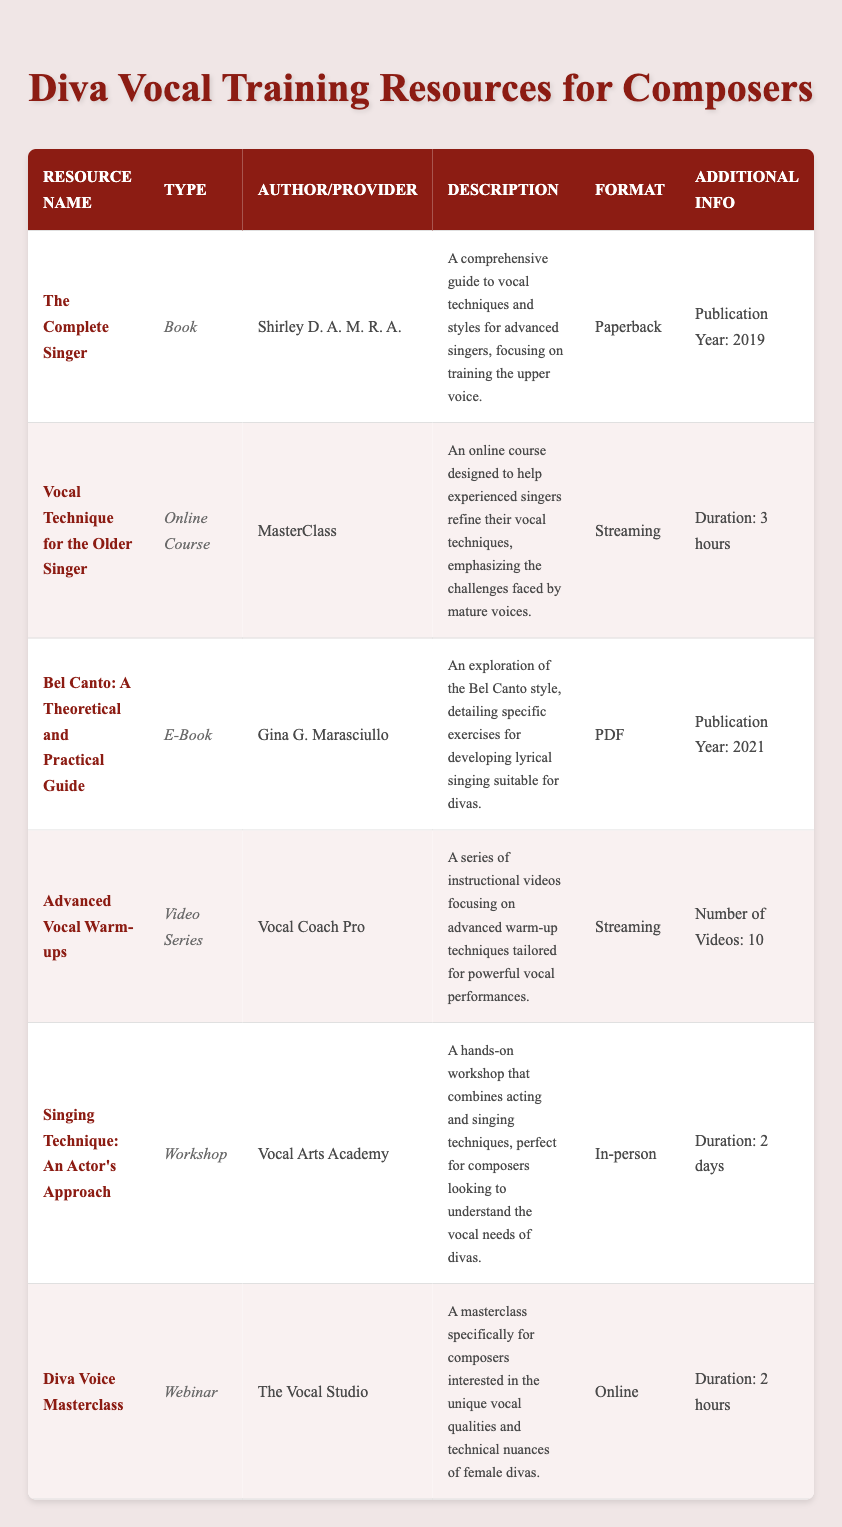What is the title of the resource aimed specifically at advanced singers? The title "The Complete Singer" directly refers to a comprehensive guide focused on vocal techniques for advanced singers.
Answer: The Complete Singer How many resources are available in the inventory table? By counting the entries listed in the inventory, there are 6 resources listed overall.
Answer: 6 Which resource provides information on Bel Canto style and who is the author? The resource "Bel Canto: A Theoretical and Practical Guide" authored by Gina G. Marasciullo offers insights into the Bel Canto style with specific exercises.
Answer: Bel Canto: A Theoretical and Practical Guide; Gina G. Marasciullo Is "Advanced Vocal Warm-ups" an online course? By checking the type listed in the table, it is categorized as a video series, not an online course.
Answer: No What is the total number of videos in the "Advanced Vocal Warm-ups" series? The specific entry for "Advanced Vocal Warm-ups" indicates there are 10 instructional videos in the series.
Answer: 10 Which type of resources has the longest duration, and what is that duration? Comparing the durations listed, the "Singing Technique: An Actor's Approach" workshop is the longest at 2 days, while most others are shorter.
Answer: In-person; 2 days How many resources are offered in an online format? The inventory includes "Vocal Technique for the Older Singer," "Diva Voice Masterclass," and "Advanced Vocal Warm-ups" when counted together, totaling to 3 resources offered online.
Answer: 3 What is the publication year of the resource "The Complete Singer"? Looking at the data for that resource, it specifies a publication year of 2019.
Answer: 2019 Which resource is designed for older singers and what is its format? The resource titled "Vocal Technique for the Older Singer" is an online course, formatted for streaming.
Answer: Vocal Technique for the Older Singer; Streaming 